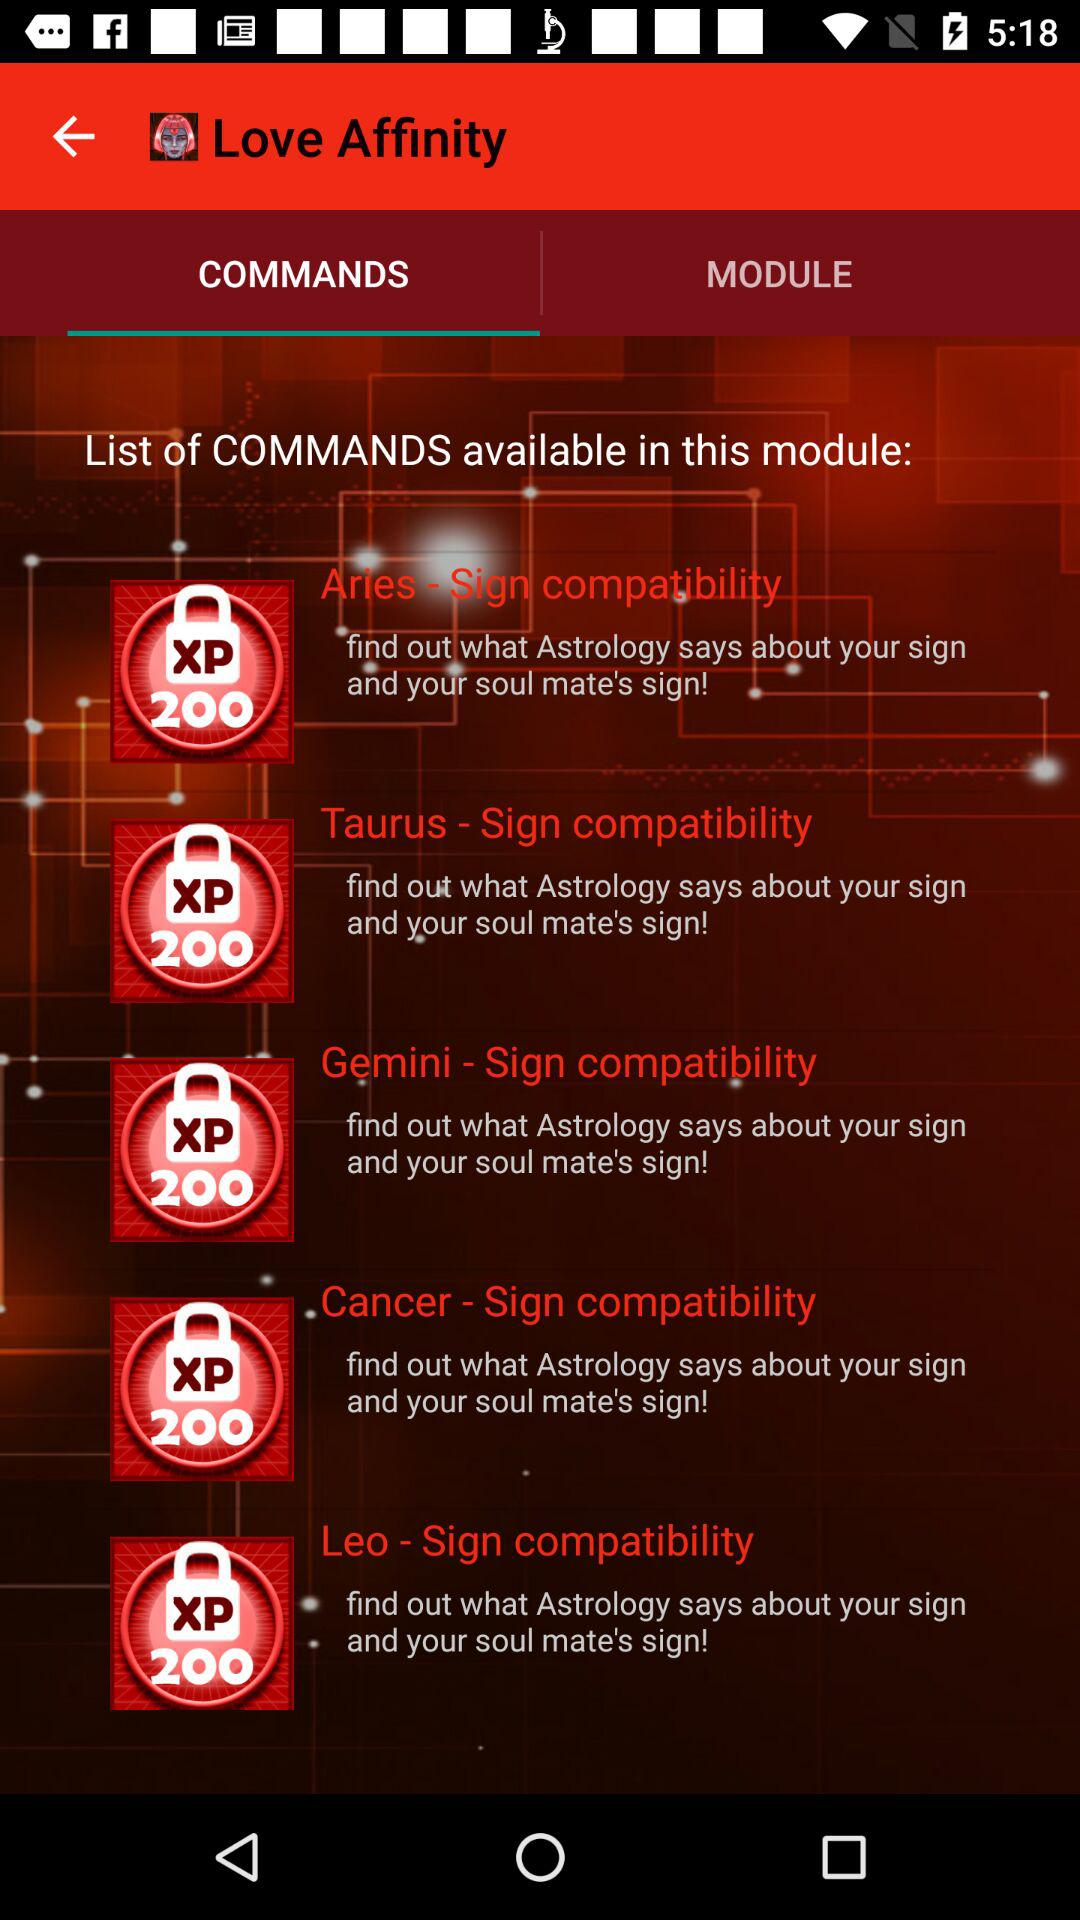What is the name of the application? The name of the application is "Love Affinity". 